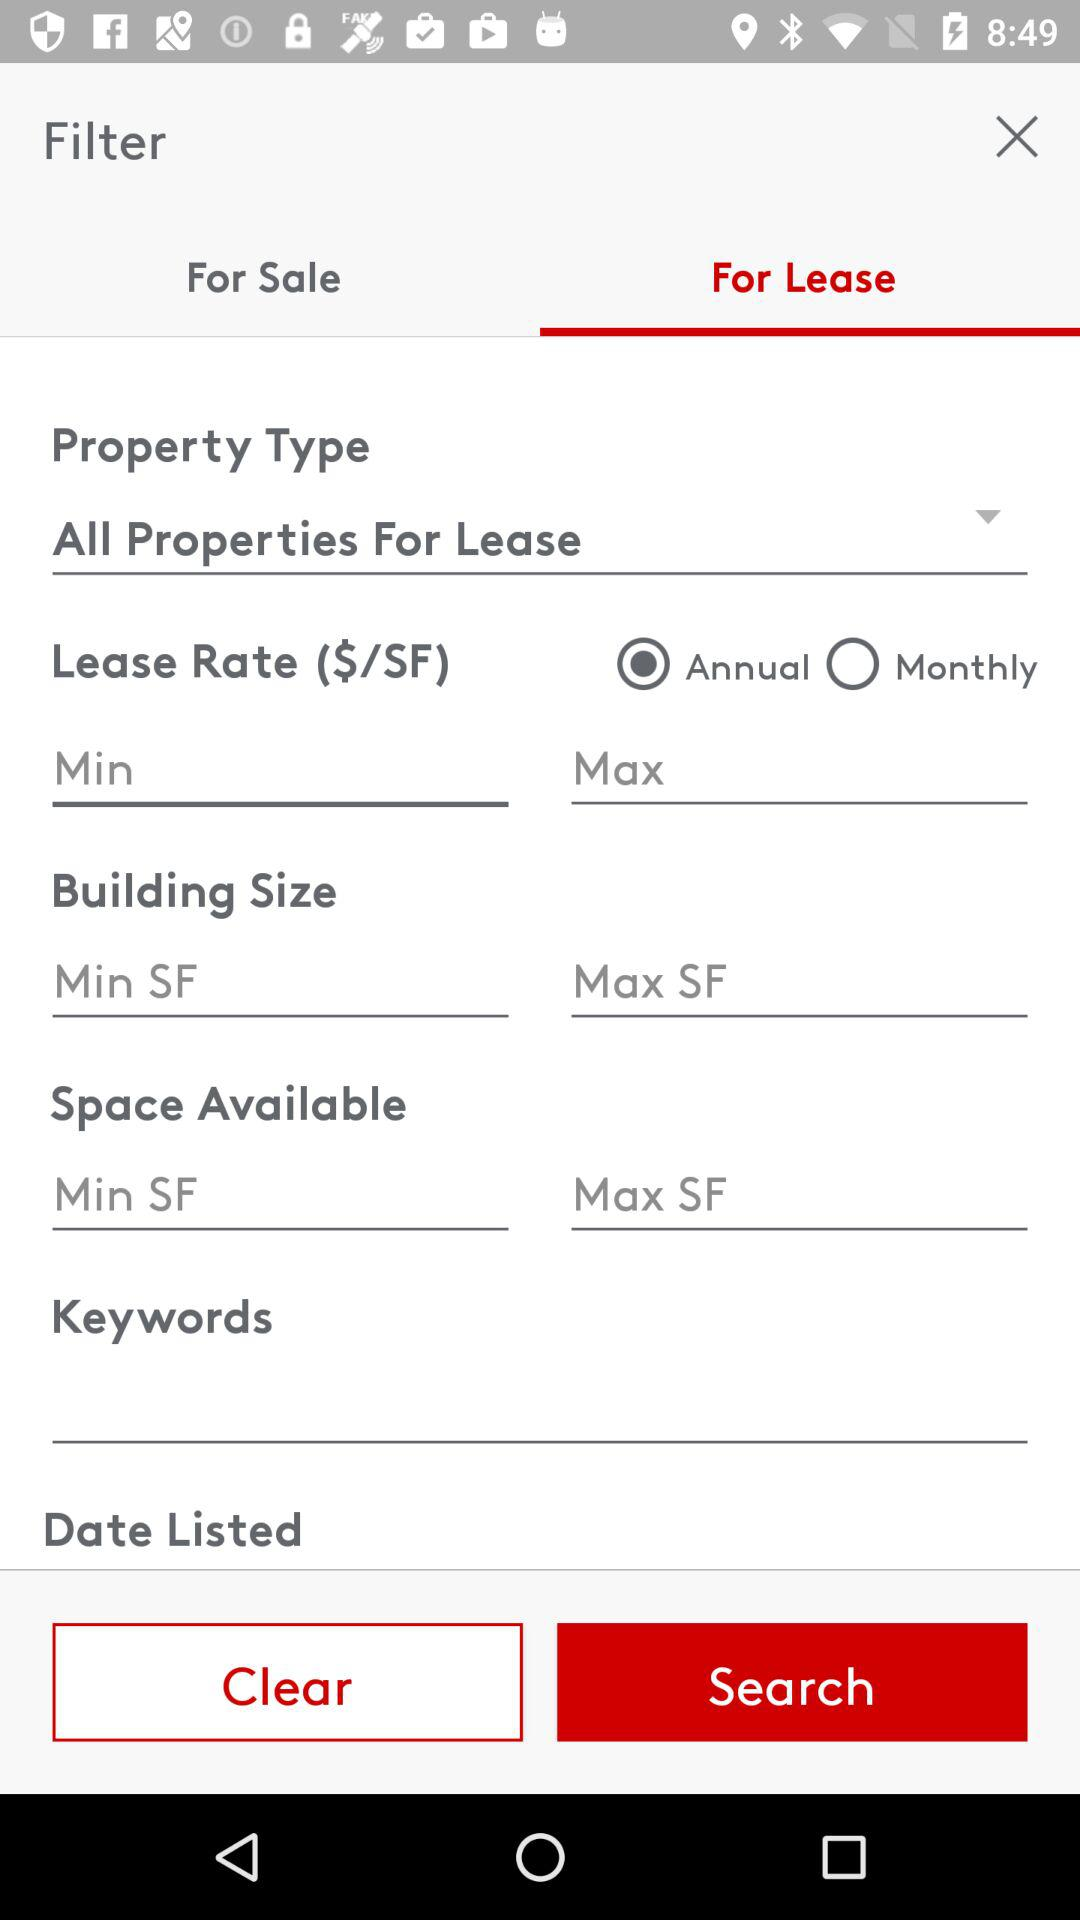What is the building size?
When the provided information is insufficient, respond with <no answer>. <no answer> 